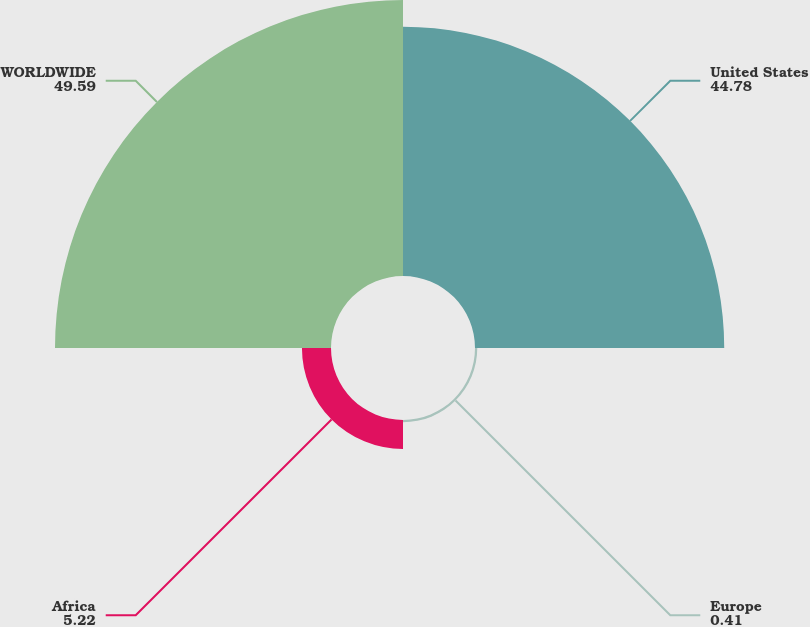<chart> <loc_0><loc_0><loc_500><loc_500><pie_chart><fcel>United States<fcel>Europe<fcel>Africa<fcel>WORLDWIDE<nl><fcel>44.78%<fcel>0.41%<fcel>5.22%<fcel>49.59%<nl></chart> 